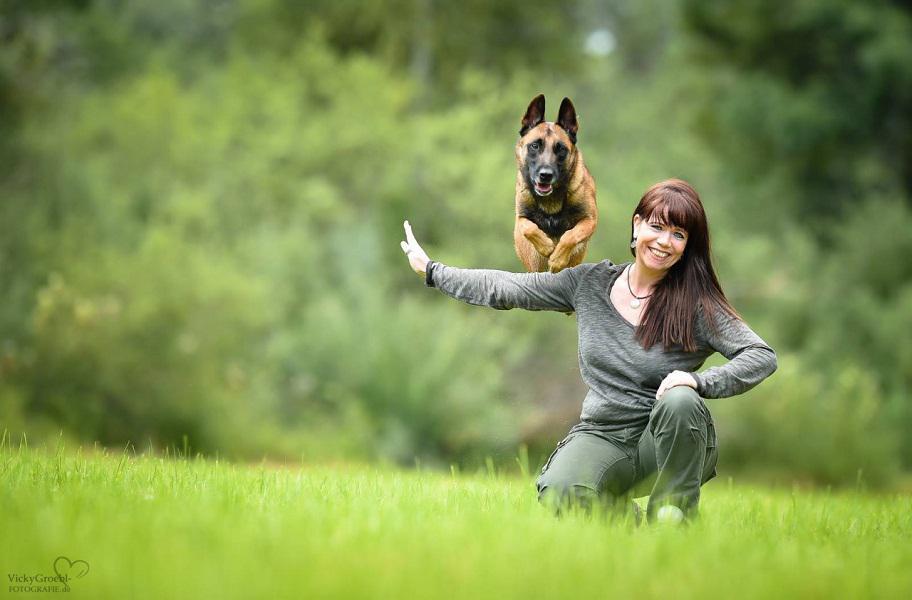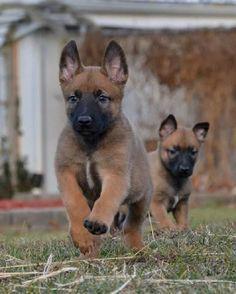The first image is the image on the left, the second image is the image on the right. Given the left and right images, does the statement "One of the dogs has it's tongue hanging out and neither of the dogs is a puppy." hold true? Answer yes or no. No. The first image is the image on the left, the second image is the image on the right. For the images displayed, is the sentence "The image on the right features exactly two animals." factually correct? Answer yes or no. Yes. 